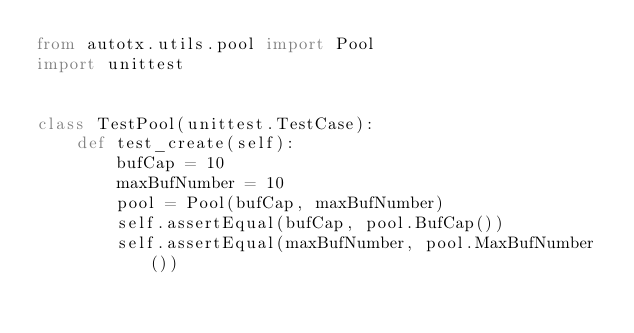Convert code to text. <code><loc_0><loc_0><loc_500><loc_500><_Python_>from autotx.utils.pool import Pool
import unittest


class TestPool(unittest.TestCase):
    def test_create(self):
        bufCap = 10
        maxBufNumber = 10
        pool = Pool(bufCap, maxBufNumber)
        self.assertEqual(bufCap, pool.BufCap())
        self.assertEqual(maxBufNumber, pool.MaxBufNumber())</code> 